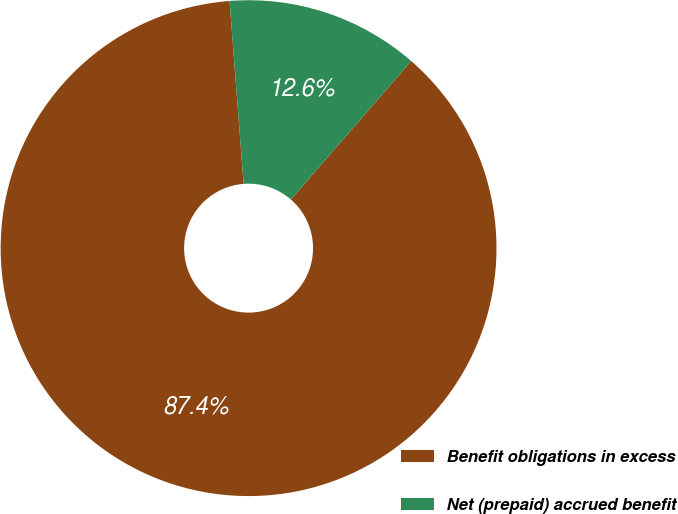<chart> <loc_0><loc_0><loc_500><loc_500><pie_chart><fcel>Benefit obligations in excess<fcel>Net (prepaid) accrued benefit<nl><fcel>87.39%<fcel>12.61%<nl></chart> 